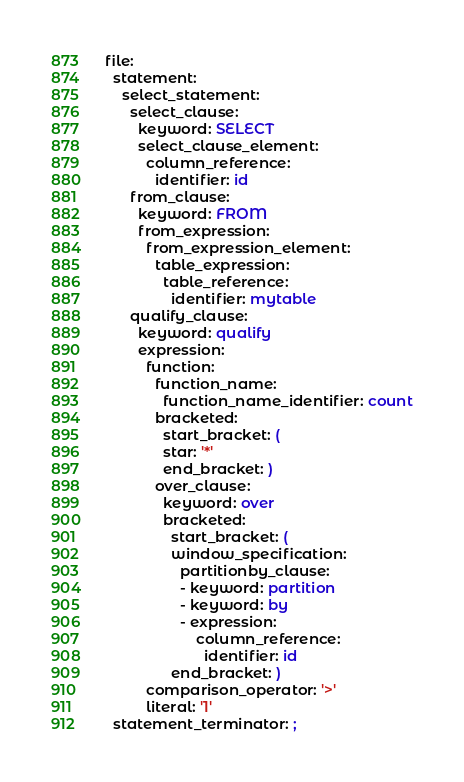<code> <loc_0><loc_0><loc_500><loc_500><_YAML_>file:
  statement:
    select_statement:
      select_clause:
        keyword: SELECT
        select_clause_element:
          column_reference:
            identifier: id
      from_clause:
        keyword: FROM
        from_expression:
          from_expression_element:
            table_expression:
              table_reference:
                identifier: mytable
      qualify_clause:
        keyword: qualify
        expression:
          function:
            function_name:
              function_name_identifier: count
            bracketed:
              start_bracket: (
              star: '*'
              end_bracket: )
            over_clause:
              keyword: over
              bracketed:
                start_bracket: (
                window_specification:
                  partitionby_clause:
                  - keyword: partition
                  - keyword: by
                  - expression:
                      column_reference:
                        identifier: id
                end_bracket: )
          comparison_operator: '>'
          literal: '1'
  statement_terminator: ;
</code> 